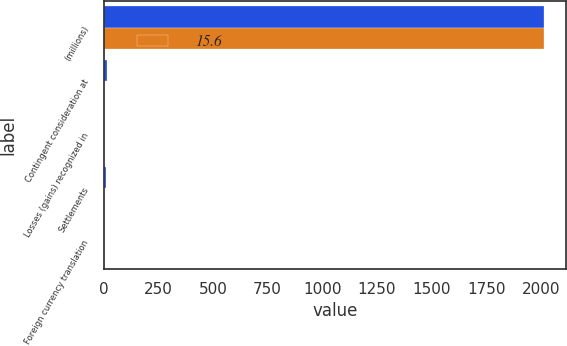Convert chart to OTSL. <chart><loc_0><loc_0><loc_500><loc_500><stacked_bar_chart><ecel><fcel>(millions)<fcel>Contingent consideration at<fcel>Losses (gains) recognized in<fcel>Settlements<fcel>Foreign currency translation<nl><fcel>nan<fcel>2016<fcel>15.6<fcel>2.4<fcel>12.6<fcel>0.6<nl><fcel>15.6<fcel>2015<fcel>1.3<fcel>0.2<fcel>1<fcel>0.5<nl></chart> 